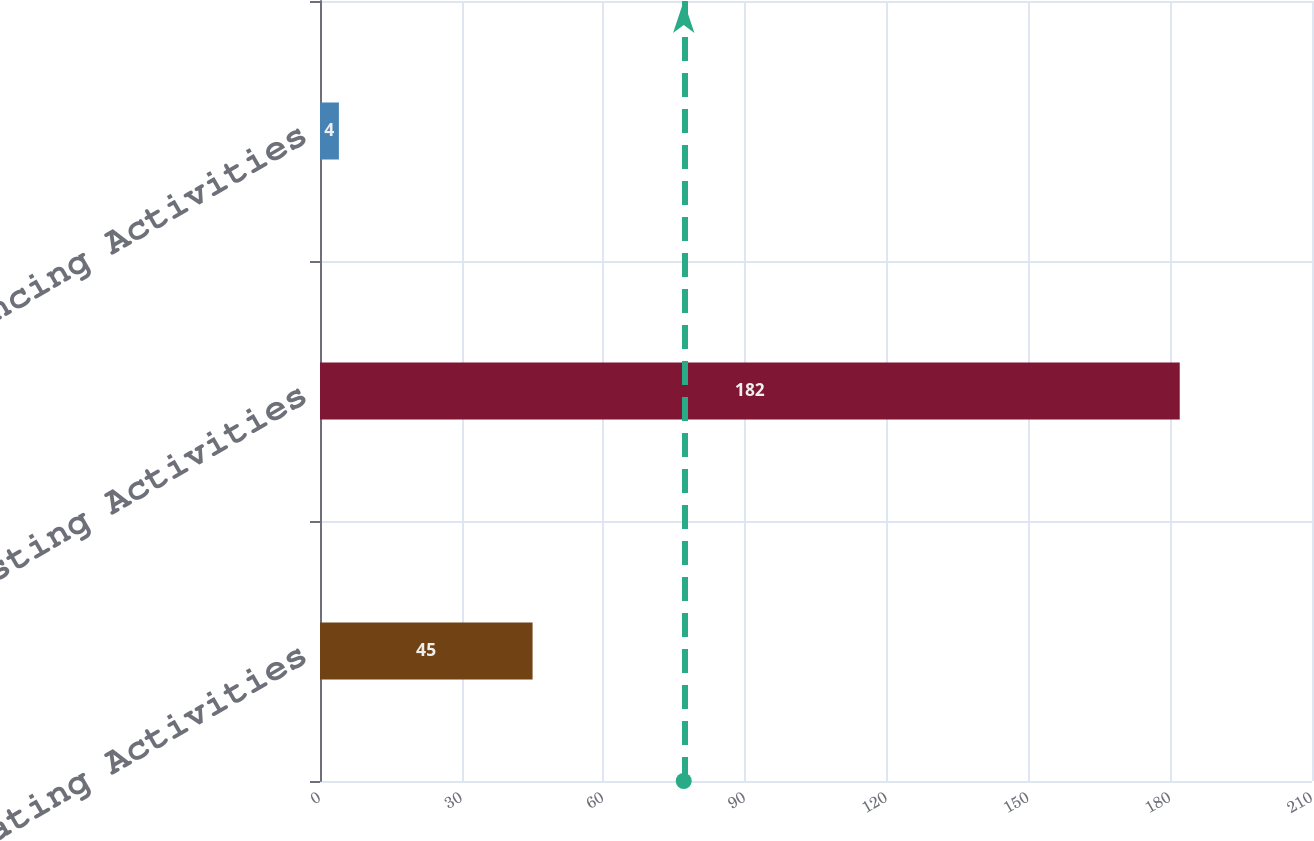Convert chart. <chart><loc_0><loc_0><loc_500><loc_500><bar_chart><fcel>Operating Activities<fcel>Investing Activities<fcel>Financing Activities<nl><fcel>45<fcel>182<fcel>4<nl></chart> 